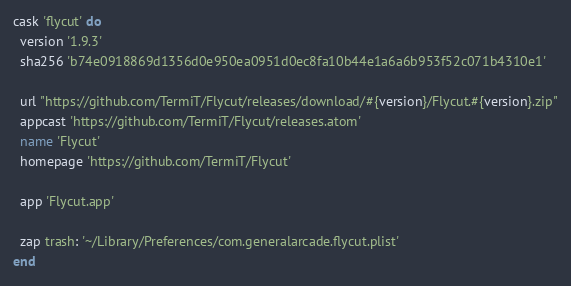<code> <loc_0><loc_0><loc_500><loc_500><_Ruby_>cask 'flycut' do
  version '1.9.3'
  sha256 'b74e0918869d1356d0e950ea0951d0ec8fa10b44e1a6a6b953f52c071b4310e1'

  url "https://github.com/TermiT/Flycut/releases/download/#{version}/Flycut.#{version}.zip"
  appcast 'https://github.com/TermiT/Flycut/releases.atom'
  name 'Flycut'
  homepage 'https://github.com/TermiT/Flycut'

  app 'Flycut.app'

  zap trash: '~/Library/Preferences/com.generalarcade.flycut.plist'
end
</code> 